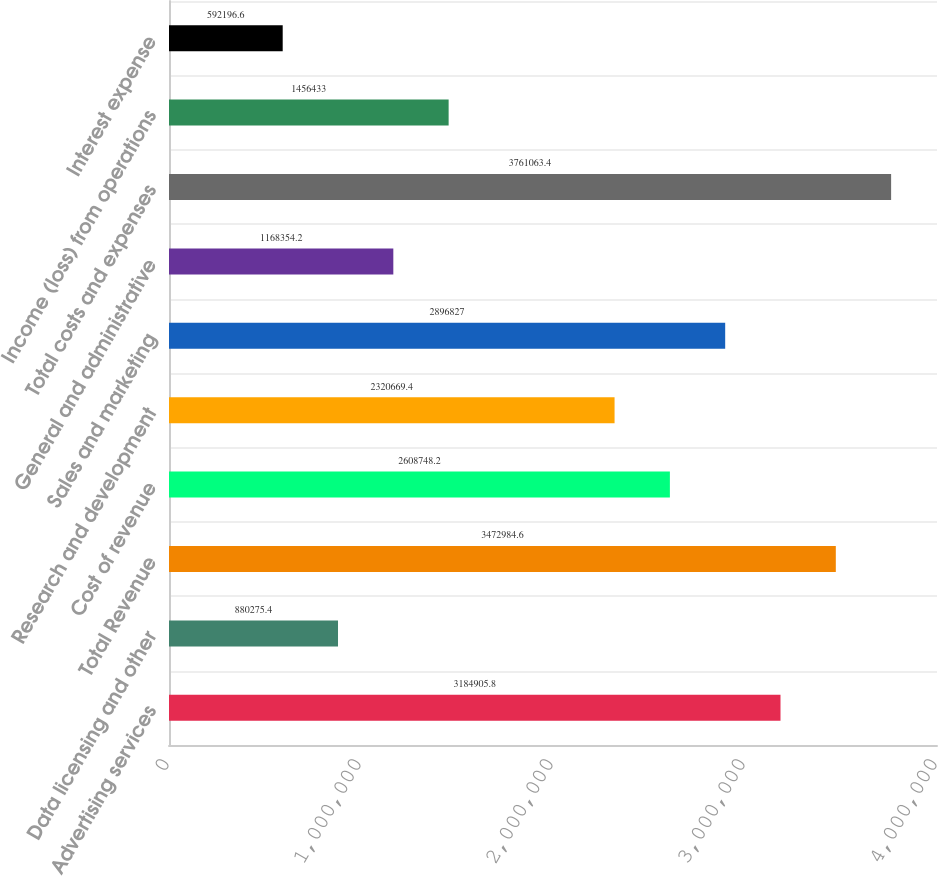<chart> <loc_0><loc_0><loc_500><loc_500><bar_chart><fcel>Advertising services<fcel>Data licensing and other<fcel>Total Revenue<fcel>Cost of revenue<fcel>Research and development<fcel>Sales and marketing<fcel>General and administrative<fcel>Total costs and expenses<fcel>Income (loss) from operations<fcel>Interest expense<nl><fcel>3.18491e+06<fcel>880275<fcel>3.47298e+06<fcel>2.60875e+06<fcel>2.32067e+06<fcel>2.89683e+06<fcel>1.16835e+06<fcel>3.76106e+06<fcel>1.45643e+06<fcel>592197<nl></chart> 